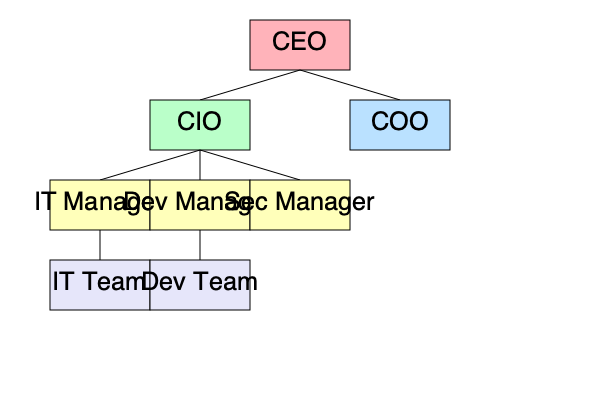In the given organizational structure, how might the hierarchical levels between the CIO and IT/Dev Teams affect the agility and efficiency of IT project management? Propose a strategy to mitigate potential communication bottlenecks and improve project outcomes. 1. Analyze the organizational structure:
   - The CIO is two levels above the IT and Dev Teams.
   - There are intermediate managers (IT Manager and Dev Manager) between the CIO and the teams.

2. Identify potential issues:
   - Information flow may be slow due to multiple hierarchical levels.
   - Decision-making processes could be delayed.
   - Teams may feel disconnected from high-level strategic decisions.
   - Managers might become bottlenecks in communication.

3. Consider the impact on IT project management:
   - Reduced agility in responding to project changes or issues.
   - Potential misalignment between strategic goals and team-level execution.
   - Increased risk of miscommunication or loss of critical information.

4. Develop a mitigation strategy:
   a) Implement a matrix structure for projects:
      - Create cross-functional project teams that report directly to project managers.
      - Project managers have a direct line to the CIO for critical decisions.

   b) Establish regular skip-level meetings:
      - CIO holds periodic meetings with team members, bypassing middle management.
      - Encourages open communication and provides insights into ground-level challenges.

   c) Utilize collaborative tools:
      - Implement project management and communication platforms accessible to all levels.
      - Ensures transparency and real-time information sharing.

   d) Empower middle managers:
      - Delegate more decision-making authority to IT and Dev Managers.
      - Reduce the need for constant escalation to the CIO level.

   e) Adopt Agile methodologies:
      - Implement Scrum or Kanban frameworks to increase team autonomy and responsiveness.
      - Regular sprint reviews involving the CIO to maintain alignment with strategic goals.

5. Expected outcomes:
   - Improved communication flow between all levels of the organization.
   - Faster decision-making and increased project agility.
   - Better alignment between strategic objectives and project execution.
   - Enhanced team morale and engagement due to increased visibility and input.

By implementing these strategies, the organization can maintain the benefits of a hierarchical structure while mitigating its potential negative impacts on IT project management efficiency and agility.
Answer: Implement a matrix structure with cross-functional teams, establish skip-level meetings, utilize collaborative tools, empower middle managers, and adopt Agile methodologies. 